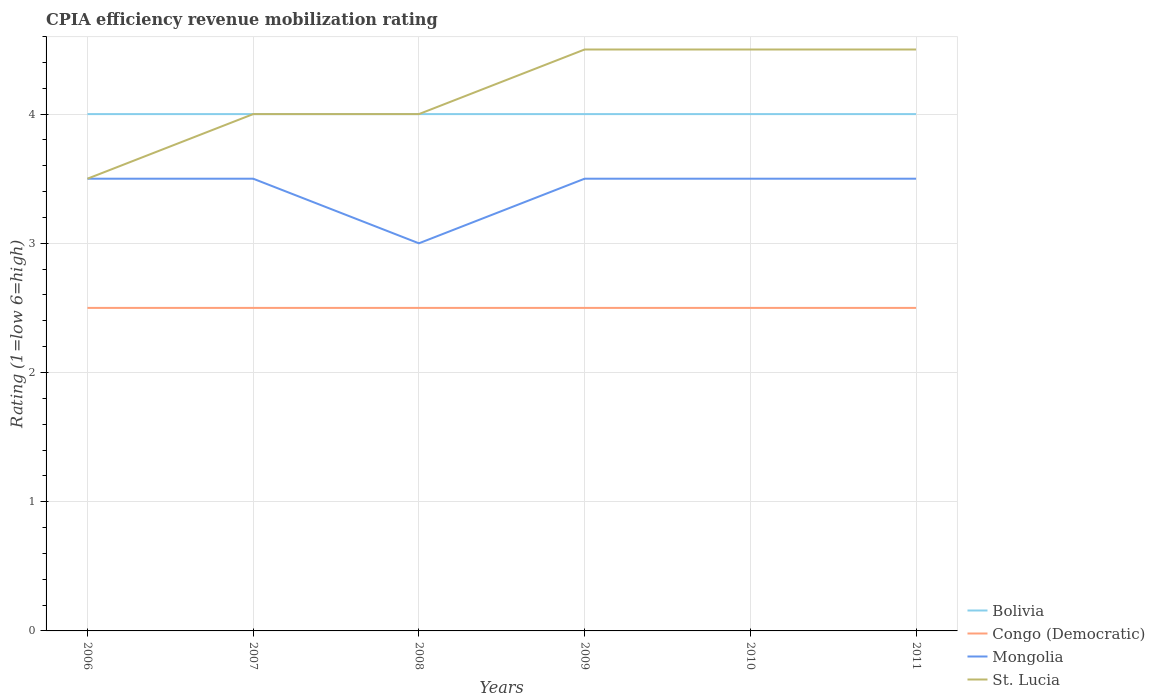How many different coloured lines are there?
Make the answer very short. 4. Is the number of lines equal to the number of legend labels?
Your answer should be compact. Yes. Across all years, what is the maximum CPIA rating in St. Lucia?
Provide a short and direct response. 3.5. In which year was the CPIA rating in St. Lucia maximum?
Offer a very short reply. 2006. Is the CPIA rating in Congo (Democratic) strictly greater than the CPIA rating in Mongolia over the years?
Offer a terse response. Yes. How many lines are there?
Keep it short and to the point. 4. What is the difference between two consecutive major ticks on the Y-axis?
Ensure brevity in your answer.  1. Are the values on the major ticks of Y-axis written in scientific E-notation?
Ensure brevity in your answer.  No. Does the graph contain grids?
Provide a short and direct response. Yes. Where does the legend appear in the graph?
Make the answer very short. Bottom right. How many legend labels are there?
Ensure brevity in your answer.  4. How are the legend labels stacked?
Your response must be concise. Vertical. What is the title of the graph?
Keep it short and to the point. CPIA efficiency revenue mobilization rating. What is the label or title of the X-axis?
Your answer should be very brief. Years. What is the Rating (1=low 6=high) in Bolivia in 2006?
Keep it short and to the point. 4. What is the Rating (1=low 6=high) of Congo (Democratic) in 2006?
Offer a terse response. 2.5. What is the Rating (1=low 6=high) in Congo (Democratic) in 2007?
Ensure brevity in your answer.  2.5. What is the Rating (1=low 6=high) in St. Lucia in 2007?
Offer a terse response. 4. What is the Rating (1=low 6=high) of Congo (Democratic) in 2008?
Your answer should be compact. 2.5. What is the Rating (1=low 6=high) of Mongolia in 2008?
Your response must be concise. 3. What is the Rating (1=low 6=high) of St. Lucia in 2009?
Ensure brevity in your answer.  4.5. What is the Rating (1=low 6=high) in Congo (Democratic) in 2010?
Provide a succinct answer. 2.5. What is the Rating (1=low 6=high) of Mongolia in 2010?
Make the answer very short. 3.5. What is the Rating (1=low 6=high) of Bolivia in 2011?
Keep it short and to the point. 4. Across all years, what is the maximum Rating (1=low 6=high) in Bolivia?
Provide a short and direct response. 4. Across all years, what is the minimum Rating (1=low 6=high) in Bolivia?
Offer a very short reply. 4. Across all years, what is the minimum Rating (1=low 6=high) of Congo (Democratic)?
Give a very brief answer. 2.5. What is the total Rating (1=low 6=high) of St. Lucia in the graph?
Give a very brief answer. 25. What is the difference between the Rating (1=low 6=high) of Bolivia in 2006 and that in 2007?
Offer a very short reply. 0. What is the difference between the Rating (1=low 6=high) in Mongolia in 2006 and that in 2007?
Provide a succinct answer. 0. What is the difference between the Rating (1=low 6=high) in St. Lucia in 2006 and that in 2007?
Provide a succinct answer. -0.5. What is the difference between the Rating (1=low 6=high) of Bolivia in 2006 and that in 2008?
Your answer should be compact. 0. What is the difference between the Rating (1=low 6=high) in Mongolia in 2006 and that in 2008?
Provide a succinct answer. 0.5. What is the difference between the Rating (1=low 6=high) of St. Lucia in 2006 and that in 2008?
Your response must be concise. -0.5. What is the difference between the Rating (1=low 6=high) of Mongolia in 2006 and that in 2009?
Keep it short and to the point. 0. What is the difference between the Rating (1=low 6=high) of Bolivia in 2006 and that in 2010?
Your response must be concise. 0. What is the difference between the Rating (1=low 6=high) of Congo (Democratic) in 2006 and that in 2010?
Keep it short and to the point. 0. What is the difference between the Rating (1=low 6=high) in Mongolia in 2006 and that in 2010?
Provide a short and direct response. 0. What is the difference between the Rating (1=low 6=high) of St. Lucia in 2006 and that in 2010?
Keep it short and to the point. -1. What is the difference between the Rating (1=low 6=high) in Bolivia in 2006 and that in 2011?
Ensure brevity in your answer.  0. What is the difference between the Rating (1=low 6=high) of Congo (Democratic) in 2006 and that in 2011?
Keep it short and to the point. 0. What is the difference between the Rating (1=low 6=high) in Mongolia in 2006 and that in 2011?
Provide a succinct answer. 0. What is the difference between the Rating (1=low 6=high) in St. Lucia in 2006 and that in 2011?
Make the answer very short. -1. What is the difference between the Rating (1=low 6=high) in Bolivia in 2007 and that in 2008?
Offer a terse response. 0. What is the difference between the Rating (1=low 6=high) in Mongolia in 2007 and that in 2008?
Keep it short and to the point. 0.5. What is the difference between the Rating (1=low 6=high) of St. Lucia in 2007 and that in 2009?
Your response must be concise. -0.5. What is the difference between the Rating (1=low 6=high) of Bolivia in 2007 and that in 2010?
Keep it short and to the point. 0. What is the difference between the Rating (1=low 6=high) in Mongolia in 2007 and that in 2010?
Provide a succinct answer. 0. What is the difference between the Rating (1=low 6=high) in St. Lucia in 2007 and that in 2010?
Offer a terse response. -0.5. What is the difference between the Rating (1=low 6=high) in Congo (Democratic) in 2007 and that in 2011?
Offer a very short reply. 0. What is the difference between the Rating (1=low 6=high) in Mongolia in 2007 and that in 2011?
Your response must be concise. 0. What is the difference between the Rating (1=low 6=high) of St. Lucia in 2007 and that in 2011?
Your answer should be compact. -0.5. What is the difference between the Rating (1=low 6=high) in Bolivia in 2008 and that in 2009?
Offer a very short reply. 0. What is the difference between the Rating (1=low 6=high) of Congo (Democratic) in 2008 and that in 2009?
Your response must be concise. 0. What is the difference between the Rating (1=low 6=high) of Mongolia in 2008 and that in 2010?
Provide a short and direct response. -0.5. What is the difference between the Rating (1=low 6=high) of Bolivia in 2008 and that in 2011?
Make the answer very short. 0. What is the difference between the Rating (1=low 6=high) of St. Lucia in 2008 and that in 2011?
Your answer should be compact. -0.5. What is the difference between the Rating (1=low 6=high) in Congo (Democratic) in 2009 and that in 2010?
Offer a very short reply. 0. What is the difference between the Rating (1=low 6=high) in Mongolia in 2009 and that in 2010?
Your response must be concise. 0. What is the difference between the Rating (1=low 6=high) of Congo (Democratic) in 2009 and that in 2011?
Keep it short and to the point. 0. What is the difference between the Rating (1=low 6=high) in St. Lucia in 2009 and that in 2011?
Your answer should be very brief. 0. What is the difference between the Rating (1=low 6=high) in Mongolia in 2010 and that in 2011?
Offer a terse response. 0. What is the difference between the Rating (1=low 6=high) in St. Lucia in 2010 and that in 2011?
Provide a succinct answer. 0. What is the difference between the Rating (1=low 6=high) in Bolivia in 2006 and the Rating (1=low 6=high) in St. Lucia in 2007?
Ensure brevity in your answer.  0. What is the difference between the Rating (1=low 6=high) of Mongolia in 2006 and the Rating (1=low 6=high) of St. Lucia in 2007?
Your answer should be compact. -0.5. What is the difference between the Rating (1=low 6=high) of Bolivia in 2006 and the Rating (1=low 6=high) of Congo (Democratic) in 2008?
Ensure brevity in your answer.  1.5. What is the difference between the Rating (1=low 6=high) in Bolivia in 2006 and the Rating (1=low 6=high) in Mongolia in 2008?
Ensure brevity in your answer.  1. What is the difference between the Rating (1=low 6=high) of Bolivia in 2006 and the Rating (1=low 6=high) of St. Lucia in 2008?
Your answer should be compact. 0. What is the difference between the Rating (1=low 6=high) in Congo (Democratic) in 2006 and the Rating (1=low 6=high) in St. Lucia in 2008?
Keep it short and to the point. -1.5. What is the difference between the Rating (1=low 6=high) of Bolivia in 2006 and the Rating (1=low 6=high) of Mongolia in 2009?
Make the answer very short. 0.5. What is the difference between the Rating (1=low 6=high) in Congo (Democratic) in 2006 and the Rating (1=low 6=high) in St. Lucia in 2009?
Ensure brevity in your answer.  -2. What is the difference between the Rating (1=low 6=high) of Bolivia in 2006 and the Rating (1=low 6=high) of St. Lucia in 2010?
Ensure brevity in your answer.  -0.5. What is the difference between the Rating (1=low 6=high) of Congo (Democratic) in 2006 and the Rating (1=low 6=high) of Mongolia in 2010?
Your response must be concise. -1. What is the difference between the Rating (1=low 6=high) of Congo (Democratic) in 2006 and the Rating (1=low 6=high) of St. Lucia in 2010?
Ensure brevity in your answer.  -2. What is the difference between the Rating (1=low 6=high) in Mongolia in 2006 and the Rating (1=low 6=high) in St. Lucia in 2010?
Offer a very short reply. -1. What is the difference between the Rating (1=low 6=high) in Bolivia in 2006 and the Rating (1=low 6=high) in Congo (Democratic) in 2011?
Offer a terse response. 1.5. What is the difference between the Rating (1=low 6=high) of Bolivia in 2006 and the Rating (1=low 6=high) of St. Lucia in 2011?
Make the answer very short. -0.5. What is the difference between the Rating (1=low 6=high) of Bolivia in 2007 and the Rating (1=low 6=high) of Congo (Democratic) in 2008?
Your answer should be very brief. 1.5. What is the difference between the Rating (1=low 6=high) of Bolivia in 2007 and the Rating (1=low 6=high) of Mongolia in 2008?
Keep it short and to the point. 1. What is the difference between the Rating (1=low 6=high) of Congo (Democratic) in 2007 and the Rating (1=low 6=high) of Mongolia in 2008?
Give a very brief answer. -0.5. What is the difference between the Rating (1=low 6=high) of Congo (Democratic) in 2007 and the Rating (1=low 6=high) of St. Lucia in 2008?
Your answer should be compact. -1.5. What is the difference between the Rating (1=low 6=high) of Mongolia in 2007 and the Rating (1=low 6=high) of St. Lucia in 2008?
Give a very brief answer. -0.5. What is the difference between the Rating (1=low 6=high) of Bolivia in 2007 and the Rating (1=low 6=high) of Mongolia in 2009?
Your answer should be very brief. 0.5. What is the difference between the Rating (1=low 6=high) of Congo (Democratic) in 2007 and the Rating (1=low 6=high) of Mongolia in 2009?
Your answer should be very brief. -1. What is the difference between the Rating (1=low 6=high) in Congo (Democratic) in 2007 and the Rating (1=low 6=high) in St. Lucia in 2009?
Ensure brevity in your answer.  -2. What is the difference between the Rating (1=low 6=high) of Mongolia in 2007 and the Rating (1=low 6=high) of St. Lucia in 2009?
Your answer should be very brief. -1. What is the difference between the Rating (1=low 6=high) in Bolivia in 2007 and the Rating (1=low 6=high) in Mongolia in 2010?
Your response must be concise. 0.5. What is the difference between the Rating (1=low 6=high) in Congo (Democratic) in 2007 and the Rating (1=low 6=high) in Mongolia in 2010?
Ensure brevity in your answer.  -1. What is the difference between the Rating (1=low 6=high) of Congo (Democratic) in 2007 and the Rating (1=low 6=high) of St. Lucia in 2010?
Your answer should be very brief. -2. What is the difference between the Rating (1=low 6=high) of Mongolia in 2007 and the Rating (1=low 6=high) of St. Lucia in 2010?
Make the answer very short. -1. What is the difference between the Rating (1=low 6=high) in Bolivia in 2007 and the Rating (1=low 6=high) in St. Lucia in 2011?
Your answer should be compact. -0.5. What is the difference between the Rating (1=low 6=high) in Mongolia in 2007 and the Rating (1=low 6=high) in St. Lucia in 2011?
Your answer should be compact. -1. What is the difference between the Rating (1=low 6=high) in Congo (Democratic) in 2008 and the Rating (1=low 6=high) in St. Lucia in 2009?
Your answer should be compact. -2. What is the difference between the Rating (1=low 6=high) in Bolivia in 2008 and the Rating (1=low 6=high) in Congo (Democratic) in 2010?
Provide a short and direct response. 1.5. What is the difference between the Rating (1=low 6=high) of Congo (Democratic) in 2008 and the Rating (1=low 6=high) of St. Lucia in 2010?
Give a very brief answer. -2. What is the difference between the Rating (1=low 6=high) of Mongolia in 2008 and the Rating (1=low 6=high) of St. Lucia in 2010?
Offer a very short reply. -1.5. What is the difference between the Rating (1=low 6=high) in Bolivia in 2008 and the Rating (1=low 6=high) in Congo (Democratic) in 2011?
Your answer should be very brief. 1.5. What is the difference between the Rating (1=low 6=high) of Bolivia in 2008 and the Rating (1=low 6=high) of Mongolia in 2011?
Your answer should be compact. 0.5. What is the difference between the Rating (1=low 6=high) of Bolivia in 2008 and the Rating (1=low 6=high) of St. Lucia in 2011?
Your answer should be compact. -0.5. What is the difference between the Rating (1=low 6=high) in Mongolia in 2008 and the Rating (1=low 6=high) in St. Lucia in 2011?
Keep it short and to the point. -1.5. What is the difference between the Rating (1=low 6=high) in Bolivia in 2009 and the Rating (1=low 6=high) in St. Lucia in 2010?
Give a very brief answer. -0.5. What is the difference between the Rating (1=low 6=high) of Congo (Democratic) in 2009 and the Rating (1=low 6=high) of St. Lucia in 2010?
Provide a succinct answer. -2. What is the difference between the Rating (1=low 6=high) of Mongolia in 2009 and the Rating (1=low 6=high) of St. Lucia in 2010?
Make the answer very short. -1. What is the difference between the Rating (1=low 6=high) of Bolivia in 2009 and the Rating (1=low 6=high) of Congo (Democratic) in 2011?
Your response must be concise. 1.5. What is the difference between the Rating (1=low 6=high) in Congo (Democratic) in 2009 and the Rating (1=low 6=high) in Mongolia in 2011?
Offer a terse response. -1. What is the difference between the Rating (1=low 6=high) of Bolivia in 2010 and the Rating (1=low 6=high) of Congo (Democratic) in 2011?
Your answer should be very brief. 1.5. What is the difference between the Rating (1=low 6=high) of Bolivia in 2010 and the Rating (1=low 6=high) of St. Lucia in 2011?
Provide a short and direct response. -0.5. What is the difference between the Rating (1=low 6=high) in Congo (Democratic) in 2010 and the Rating (1=low 6=high) in Mongolia in 2011?
Offer a very short reply. -1. What is the difference between the Rating (1=low 6=high) in Congo (Democratic) in 2010 and the Rating (1=low 6=high) in St. Lucia in 2011?
Your response must be concise. -2. What is the difference between the Rating (1=low 6=high) in Mongolia in 2010 and the Rating (1=low 6=high) in St. Lucia in 2011?
Ensure brevity in your answer.  -1. What is the average Rating (1=low 6=high) in Mongolia per year?
Provide a short and direct response. 3.42. What is the average Rating (1=low 6=high) of St. Lucia per year?
Your answer should be compact. 4.17. In the year 2006, what is the difference between the Rating (1=low 6=high) in Bolivia and Rating (1=low 6=high) in St. Lucia?
Ensure brevity in your answer.  0.5. In the year 2006, what is the difference between the Rating (1=low 6=high) of Congo (Democratic) and Rating (1=low 6=high) of Mongolia?
Ensure brevity in your answer.  -1. In the year 2006, what is the difference between the Rating (1=low 6=high) of Congo (Democratic) and Rating (1=low 6=high) of St. Lucia?
Make the answer very short. -1. In the year 2006, what is the difference between the Rating (1=low 6=high) in Mongolia and Rating (1=low 6=high) in St. Lucia?
Keep it short and to the point. 0. In the year 2007, what is the difference between the Rating (1=low 6=high) in Bolivia and Rating (1=low 6=high) in Congo (Democratic)?
Your response must be concise. 1.5. In the year 2007, what is the difference between the Rating (1=low 6=high) in Bolivia and Rating (1=low 6=high) in Mongolia?
Provide a short and direct response. 0.5. In the year 2007, what is the difference between the Rating (1=low 6=high) of Mongolia and Rating (1=low 6=high) of St. Lucia?
Ensure brevity in your answer.  -0.5. In the year 2008, what is the difference between the Rating (1=low 6=high) of Bolivia and Rating (1=low 6=high) of Mongolia?
Your answer should be compact. 1. In the year 2008, what is the difference between the Rating (1=low 6=high) of Bolivia and Rating (1=low 6=high) of St. Lucia?
Your answer should be compact. 0. In the year 2008, what is the difference between the Rating (1=low 6=high) of Congo (Democratic) and Rating (1=low 6=high) of Mongolia?
Your answer should be compact. -0.5. In the year 2008, what is the difference between the Rating (1=low 6=high) in Congo (Democratic) and Rating (1=low 6=high) in St. Lucia?
Provide a succinct answer. -1.5. In the year 2009, what is the difference between the Rating (1=low 6=high) of Bolivia and Rating (1=low 6=high) of Congo (Democratic)?
Your answer should be very brief. 1.5. In the year 2009, what is the difference between the Rating (1=low 6=high) in Bolivia and Rating (1=low 6=high) in Mongolia?
Provide a short and direct response. 0.5. In the year 2009, what is the difference between the Rating (1=low 6=high) in Congo (Democratic) and Rating (1=low 6=high) in Mongolia?
Offer a terse response. -1. In the year 2010, what is the difference between the Rating (1=low 6=high) in Bolivia and Rating (1=low 6=high) in Congo (Democratic)?
Keep it short and to the point. 1.5. In the year 2010, what is the difference between the Rating (1=low 6=high) in Bolivia and Rating (1=low 6=high) in Mongolia?
Keep it short and to the point. 0.5. In the year 2010, what is the difference between the Rating (1=low 6=high) in Congo (Democratic) and Rating (1=low 6=high) in Mongolia?
Your answer should be very brief. -1. In the year 2011, what is the difference between the Rating (1=low 6=high) of Bolivia and Rating (1=low 6=high) of Congo (Democratic)?
Make the answer very short. 1.5. In the year 2011, what is the difference between the Rating (1=low 6=high) of Bolivia and Rating (1=low 6=high) of Mongolia?
Offer a terse response. 0.5. In the year 2011, what is the difference between the Rating (1=low 6=high) in Congo (Democratic) and Rating (1=low 6=high) in St. Lucia?
Your answer should be compact. -2. What is the ratio of the Rating (1=low 6=high) in St. Lucia in 2006 to that in 2007?
Keep it short and to the point. 0.88. What is the ratio of the Rating (1=low 6=high) of Congo (Democratic) in 2006 to that in 2008?
Offer a terse response. 1. What is the ratio of the Rating (1=low 6=high) in Congo (Democratic) in 2006 to that in 2009?
Make the answer very short. 1. What is the ratio of the Rating (1=low 6=high) of St. Lucia in 2006 to that in 2009?
Your response must be concise. 0.78. What is the ratio of the Rating (1=low 6=high) of Congo (Democratic) in 2006 to that in 2010?
Your response must be concise. 1. What is the ratio of the Rating (1=low 6=high) of St. Lucia in 2006 to that in 2010?
Offer a very short reply. 0.78. What is the ratio of the Rating (1=low 6=high) of Bolivia in 2006 to that in 2011?
Provide a succinct answer. 1. What is the ratio of the Rating (1=low 6=high) in Mongolia in 2006 to that in 2011?
Ensure brevity in your answer.  1. What is the ratio of the Rating (1=low 6=high) of Bolivia in 2007 to that in 2009?
Your answer should be compact. 1. What is the ratio of the Rating (1=low 6=high) in Congo (Democratic) in 2007 to that in 2009?
Provide a short and direct response. 1. What is the ratio of the Rating (1=low 6=high) in St. Lucia in 2007 to that in 2009?
Provide a short and direct response. 0.89. What is the ratio of the Rating (1=low 6=high) in Bolivia in 2007 to that in 2010?
Make the answer very short. 1. What is the ratio of the Rating (1=low 6=high) of Congo (Democratic) in 2007 to that in 2010?
Offer a terse response. 1. What is the ratio of the Rating (1=low 6=high) in Mongolia in 2007 to that in 2010?
Ensure brevity in your answer.  1. What is the ratio of the Rating (1=low 6=high) of St. Lucia in 2007 to that in 2010?
Make the answer very short. 0.89. What is the ratio of the Rating (1=low 6=high) in Bolivia in 2007 to that in 2011?
Your answer should be compact. 1. What is the ratio of the Rating (1=low 6=high) in Congo (Democratic) in 2007 to that in 2011?
Offer a very short reply. 1. What is the ratio of the Rating (1=low 6=high) in St. Lucia in 2007 to that in 2011?
Your response must be concise. 0.89. What is the ratio of the Rating (1=low 6=high) in Bolivia in 2008 to that in 2009?
Your response must be concise. 1. What is the ratio of the Rating (1=low 6=high) in Congo (Democratic) in 2008 to that in 2009?
Offer a very short reply. 1. What is the ratio of the Rating (1=low 6=high) of Mongolia in 2008 to that in 2009?
Your response must be concise. 0.86. What is the ratio of the Rating (1=low 6=high) of Bolivia in 2008 to that in 2011?
Your answer should be very brief. 1. What is the ratio of the Rating (1=low 6=high) in Congo (Democratic) in 2008 to that in 2011?
Provide a short and direct response. 1. What is the ratio of the Rating (1=low 6=high) in Mongolia in 2008 to that in 2011?
Offer a very short reply. 0.86. What is the ratio of the Rating (1=low 6=high) in St. Lucia in 2008 to that in 2011?
Make the answer very short. 0.89. What is the ratio of the Rating (1=low 6=high) in Mongolia in 2009 to that in 2010?
Provide a succinct answer. 1. What is the ratio of the Rating (1=low 6=high) in St. Lucia in 2009 to that in 2010?
Offer a very short reply. 1. What is the ratio of the Rating (1=low 6=high) of Bolivia in 2009 to that in 2011?
Your response must be concise. 1. What is the ratio of the Rating (1=low 6=high) in Mongolia in 2009 to that in 2011?
Your response must be concise. 1. What is the ratio of the Rating (1=low 6=high) of St. Lucia in 2009 to that in 2011?
Offer a terse response. 1. What is the ratio of the Rating (1=low 6=high) in Bolivia in 2010 to that in 2011?
Your answer should be compact. 1. What is the ratio of the Rating (1=low 6=high) of Mongolia in 2010 to that in 2011?
Keep it short and to the point. 1. What is the ratio of the Rating (1=low 6=high) in St. Lucia in 2010 to that in 2011?
Offer a terse response. 1. What is the difference between the highest and the second highest Rating (1=low 6=high) in Bolivia?
Provide a short and direct response. 0. What is the difference between the highest and the second highest Rating (1=low 6=high) in Mongolia?
Make the answer very short. 0. What is the difference between the highest and the second highest Rating (1=low 6=high) in St. Lucia?
Make the answer very short. 0. What is the difference between the highest and the lowest Rating (1=low 6=high) in Congo (Democratic)?
Your answer should be very brief. 0. What is the difference between the highest and the lowest Rating (1=low 6=high) in Mongolia?
Give a very brief answer. 0.5. 